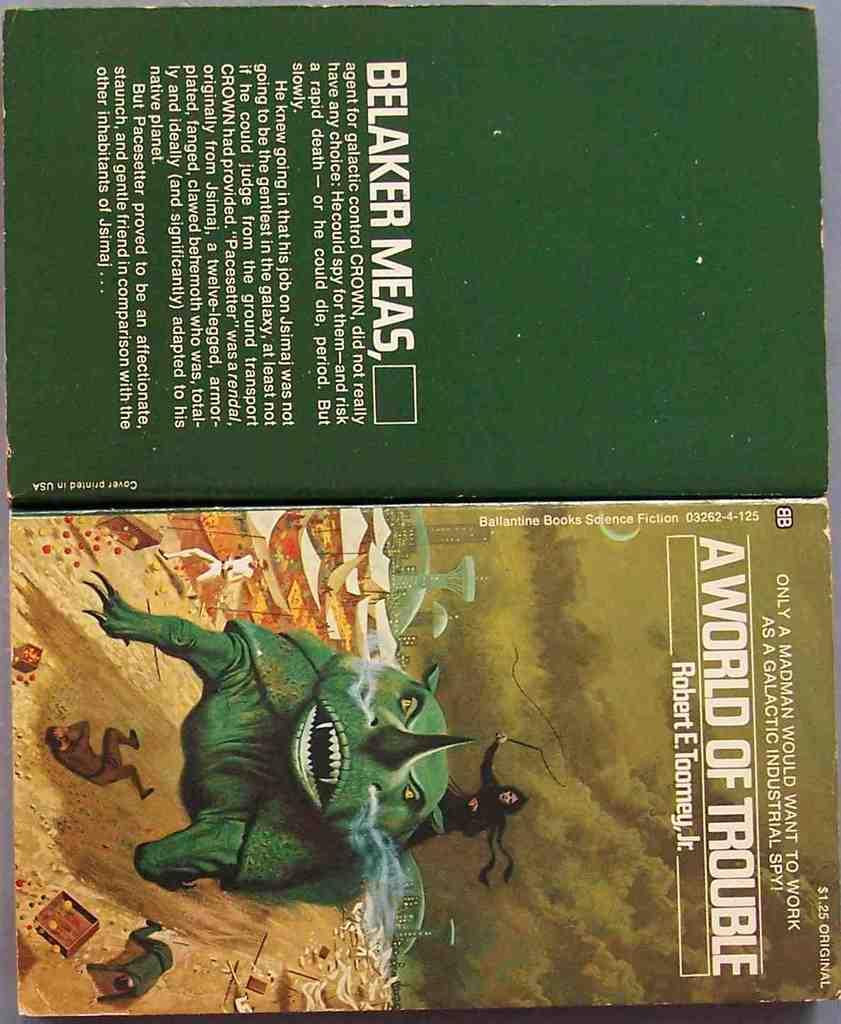<image>
Offer a succinct explanation of the picture presented. A color scan shows the cover and back of the book "A World of Trouble" by Robert Toomey, Jr. 